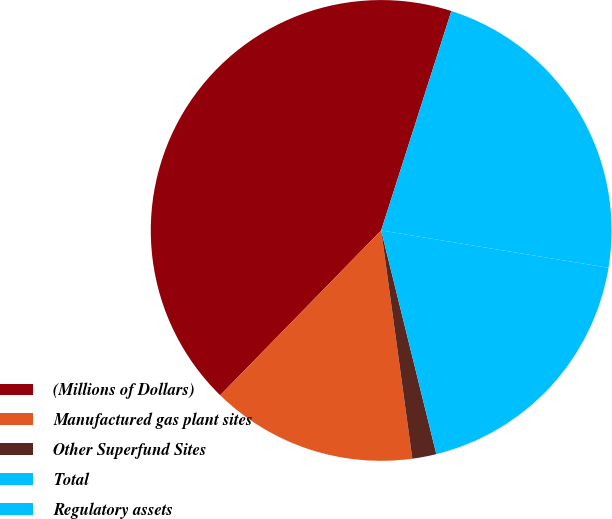Convert chart to OTSL. <chart><loc_0><loc_0><loc_500><loc_500><pie_chart><fcel>(Millions of Dollars)<fcel>Manufactured gas plant sites<fcel>Other Superfund Sites<fcel>Total<fcel>Regulatory assets<nl><fcel>42.61%<fcel>14.47%<fcel>1.69%<fcel>18.56%<fcel>22.66%<nl></chart> 